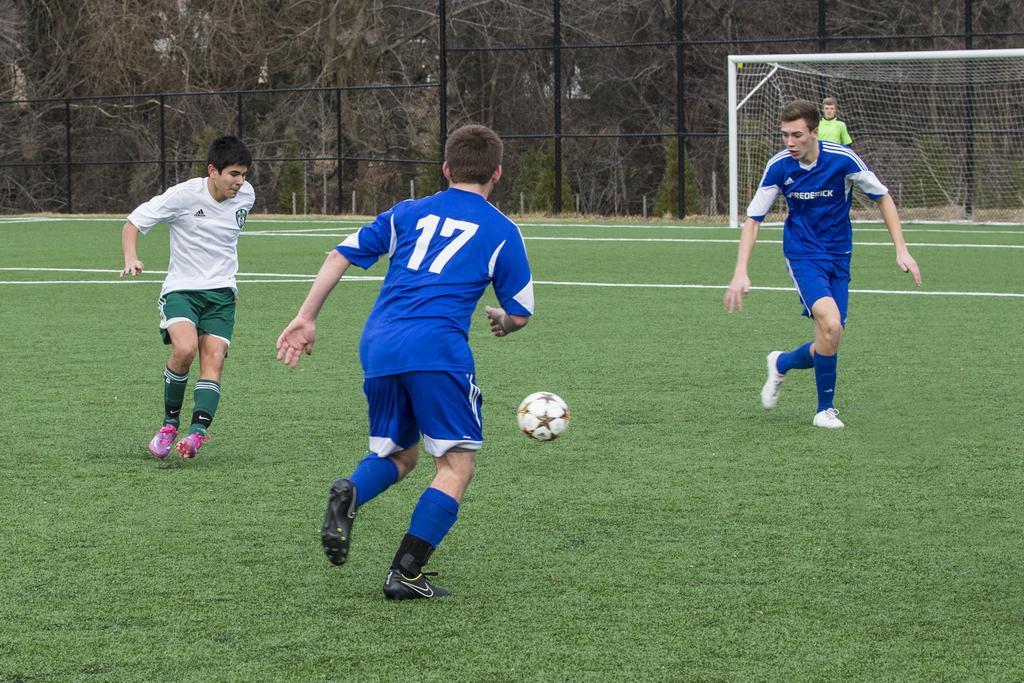Can you describe this image briefly? In this picture we can see a ball, three people on the ground and in the background we can see the grass, football net, person, fence and trees. 